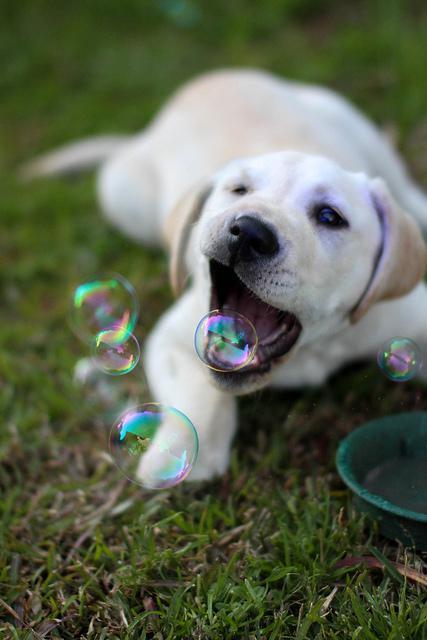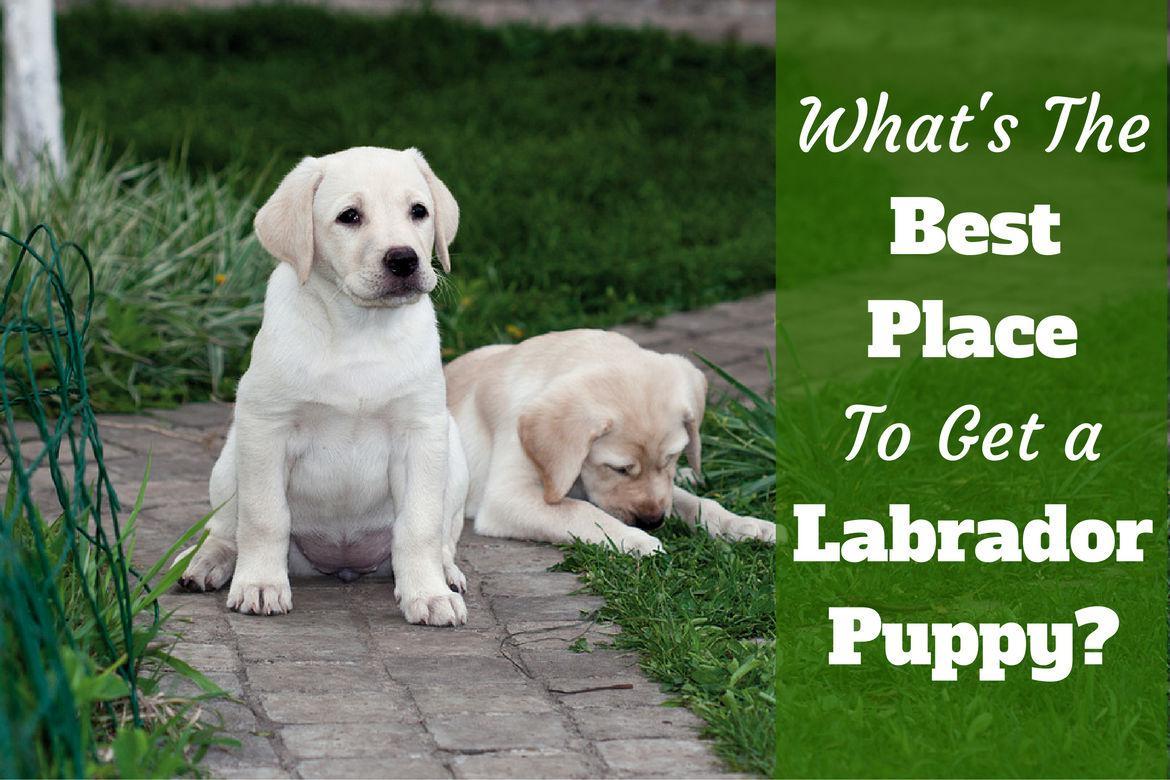The first image is the image on the left, the second image is the image on the right. For the images shown, is this caption "There are at least three dogs in the right image." true? Answer yes or no. No. The first image is the image on the left, the second image is the image on the right. Given the left and right images, does the statement "Atleast 4 dogs total" hold true? Answer yes or no. No. 